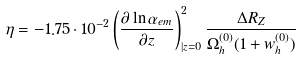Convert formula to latex. <formula><loc_0><loc_0><loc_500><loc_500>\eta = - 1 . 7 5 \cdot 1 0 ^ { - 2 } \left ( \frac { \partial \ln \alpha _ { e m } } { \partial z } \right ) _ { | z = 0 } ^ { 2 } \frac { \Delta R _ { Z } } { \Omega _ { h } ^ { ( 0 ) } ( 1 + w _ { h } ^ { ( 0 ) } ) }</formula> 